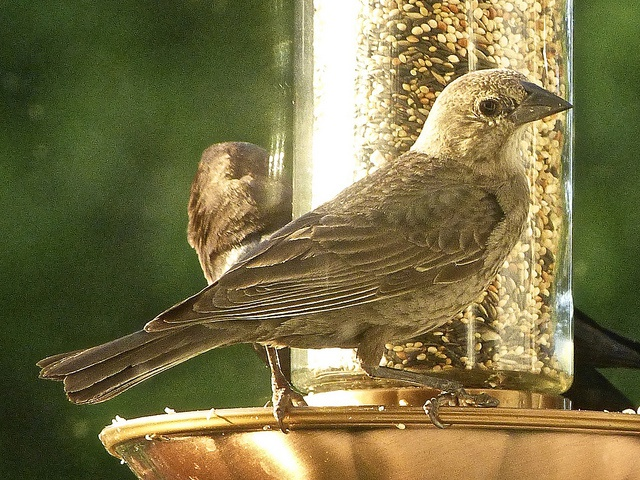Describe the objects in this image and their specific colors. I can see bird in darkgreen, olive, tan, and black tones, bottle in darkgreen, ivory, khaki, tan, and olive tones, and bird in darkgreen, olive, and tan tones in this image. 